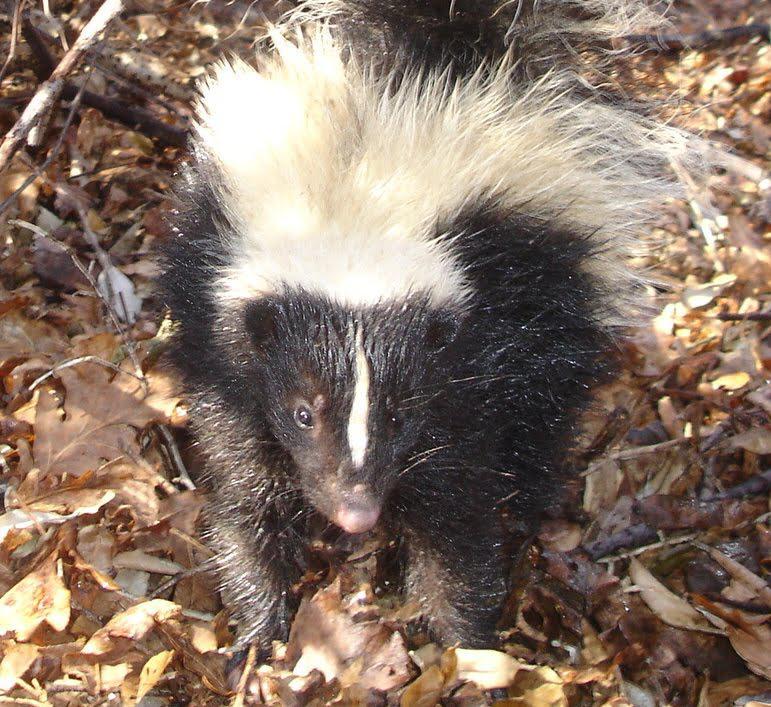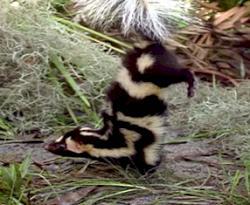The first image is the image on the left, the second image is the image on the right. Given the left and right images, does the statement "The left image features at least one skunk with a bold white stripe that starts at its head, and the right image features a skunk with more random and numerous stripes." hold true? Answer yes or no. Yes. 